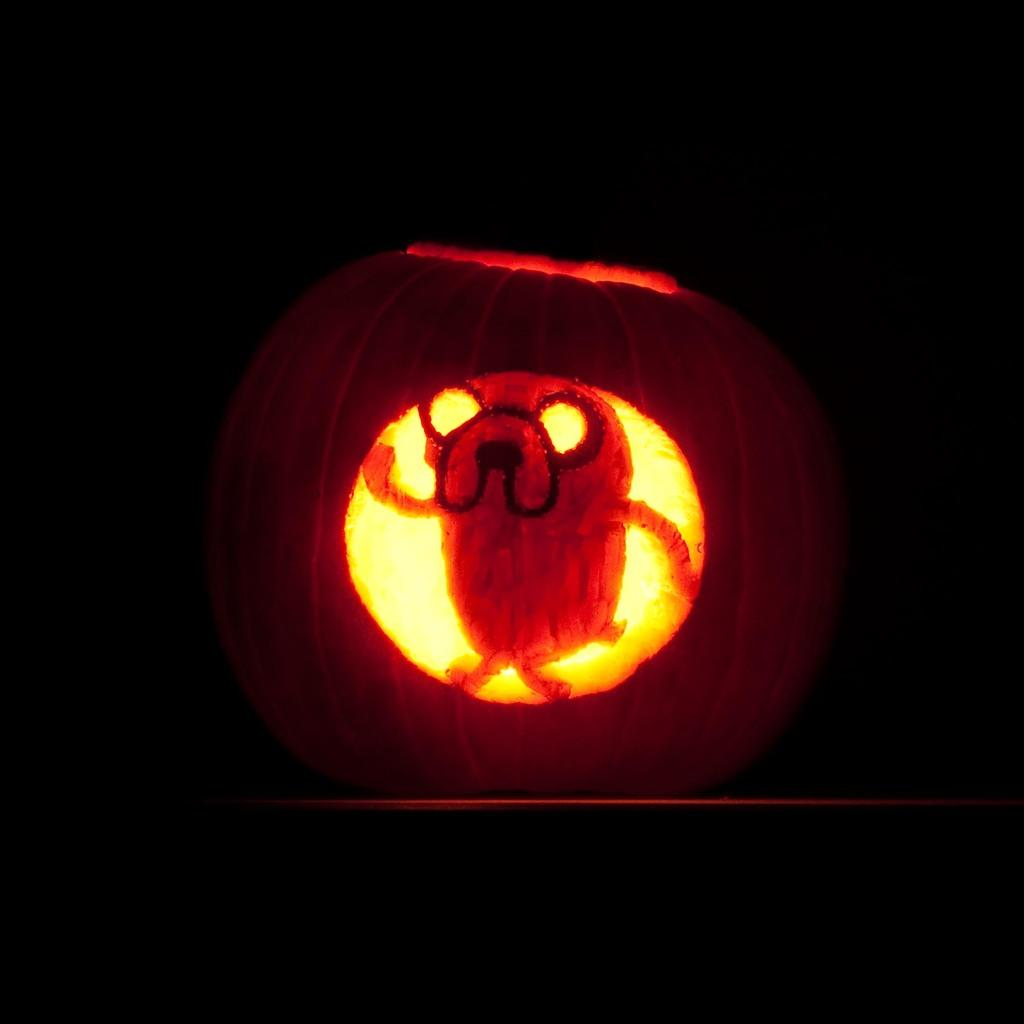What is the main subject of the image? There is a Halloween pumpkin in the image. Can you describe the background of the image? The background of the image is dark. Where is the faucet located in the image? There is no faucet present in the image. What type of trail can be seen in the image? There is no trail present in the image. 